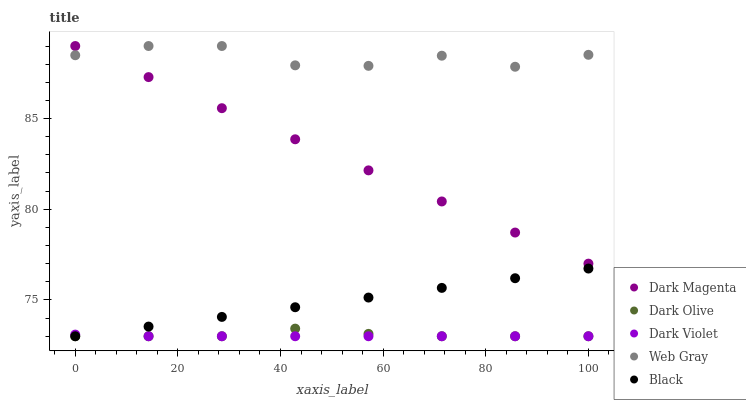Does Dark Violet have the minimum area under the curve?
Answer yes or no. Yes. Does Web Gray have the maximum area under the curve?
Answer yes or no. Yes. Does Dark Olive have the minimum area under the curve?
Answer yes or no. No. Does Dark Olive have the maximum area under the curve?
Answer yes or no. No. Is Dark Magenta the smoothest?
Answer yes or no. Yes. Is Web Gray the roughest?
Answer yes or no. Yes. Is Dark Olive the smoothest?
Answer yes or no. No. Is Dark Olive the roughest?
Answer yes or no. No. Does Black have the lowest value?
Answer yes or no. Yes. Does Web Gray have the lowest value?
Answer yes or no. No. Does Dark Magenta have the highest value?
Answer yes or no. Yes. Does Dark Olive have the highest value?
Answer yes or no. No. Is Dark Olive less than Dark Magenta?
Answer yes or no. Yes. Is Dark Magenta greater than Dark Olive?
Answer yes or no. Yes. Does Dark Magenta intersect Web Gray?
Answer yes or no. Yes. Is Dark Magenta less than Web Gray?
Answer yes or no. No. Is Dark Magenta greater than Web Gray?
Answer yes or no. No. Does Dark Olive intersect Dark Magenta?
Answer yes or no. No. 